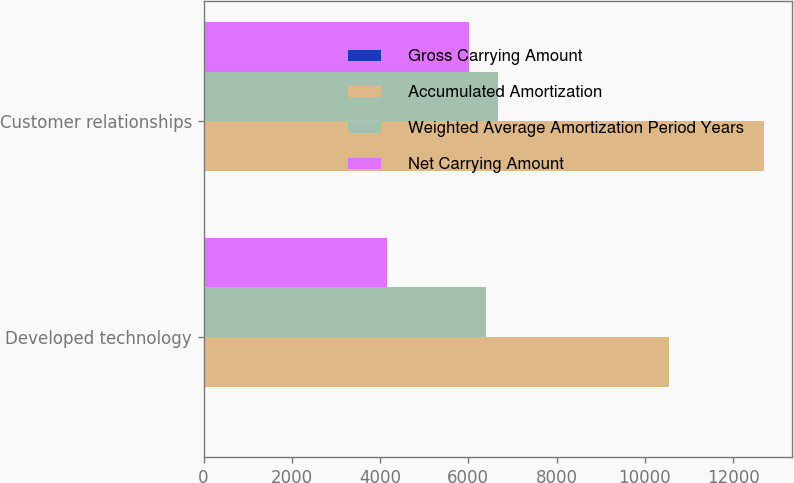<chart> <loc_0><loc_0><loc_500><loc_500><stacked_bar_chart><ecel><fcel>Developed technology<fcel>Customer relationships<nl><fcel>Gross Carrying Amount<fcel>10<fcel>10<nl><fcel>Accumulated Amortization<fcel>10550<fcel>12700<nl><fcel>Weighted Average Amortization Period Years<fcel>6399<fcel>6678<nl><fcel>Net Carrying Amount<fcel>4151<fcel>6022<nl></chart> 